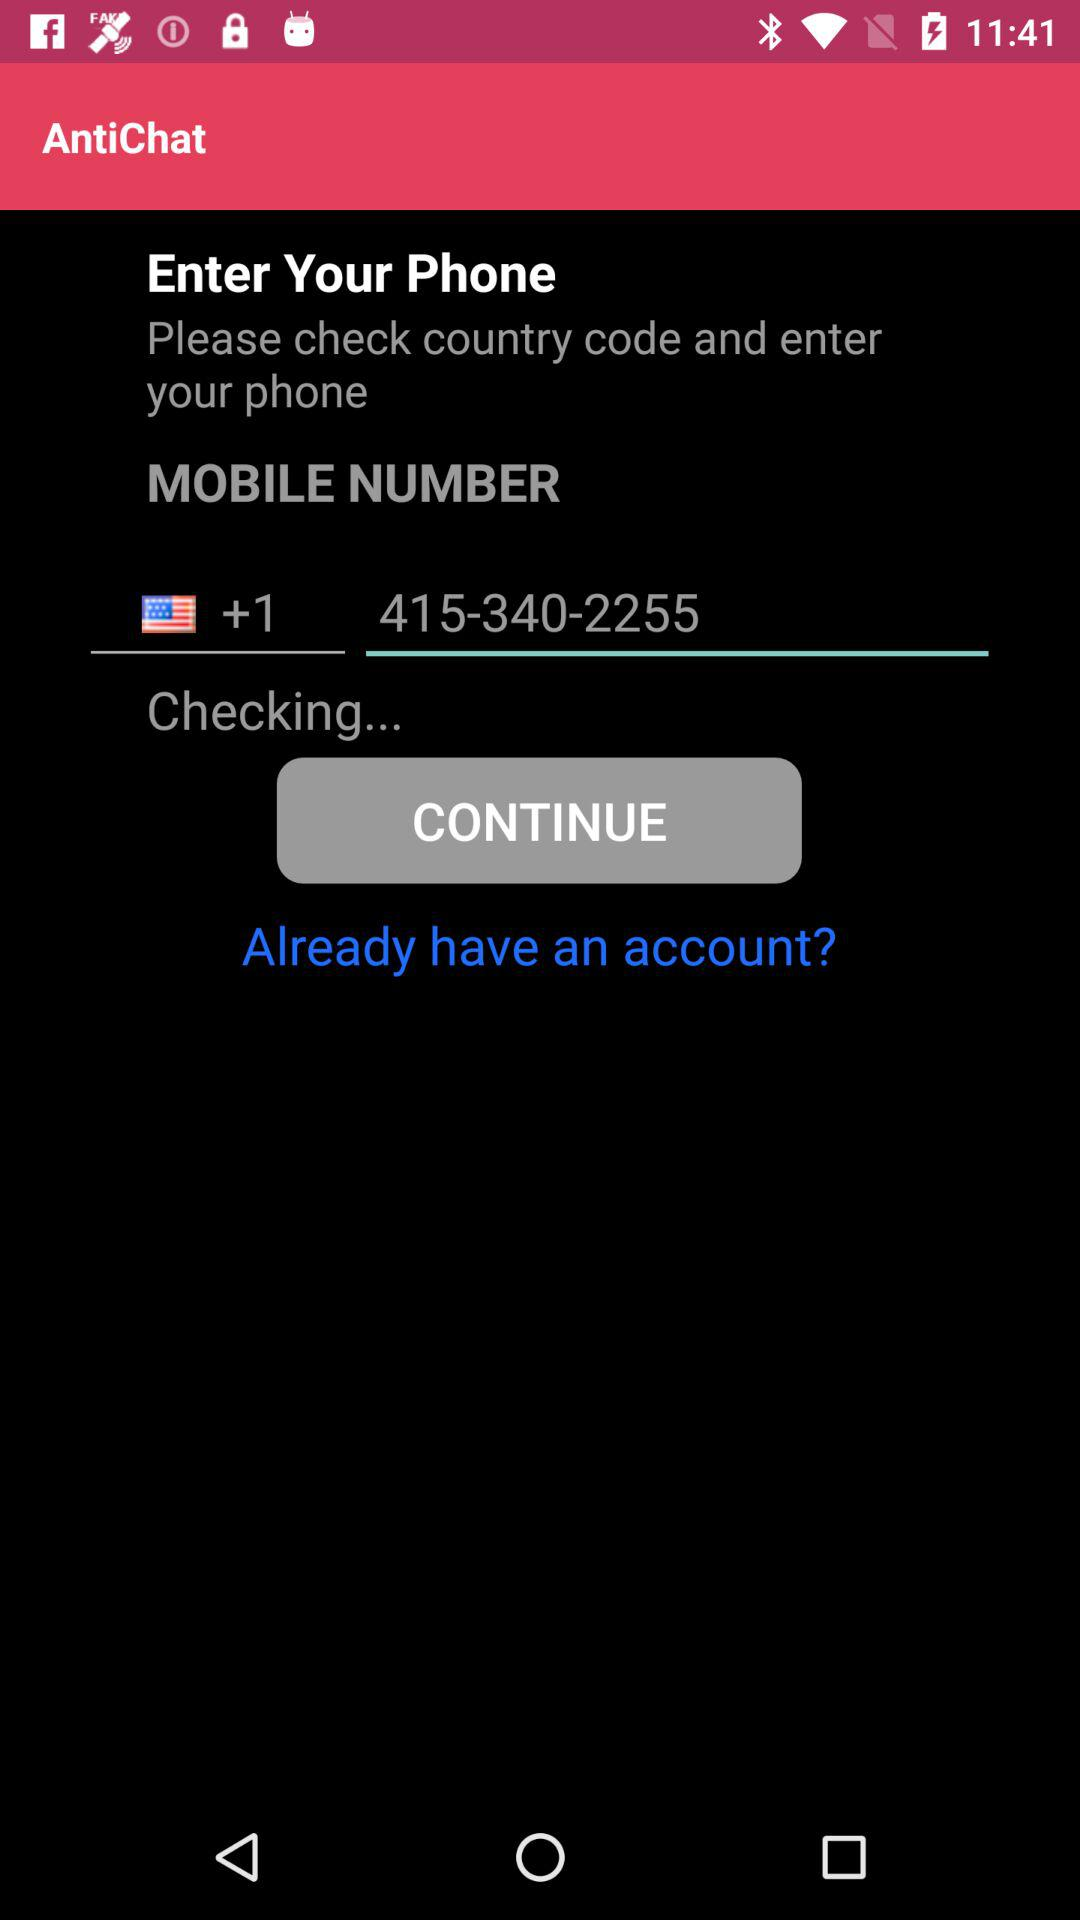How many text inputs are on the screen?
Answer the question using a single word or phrase. 2 